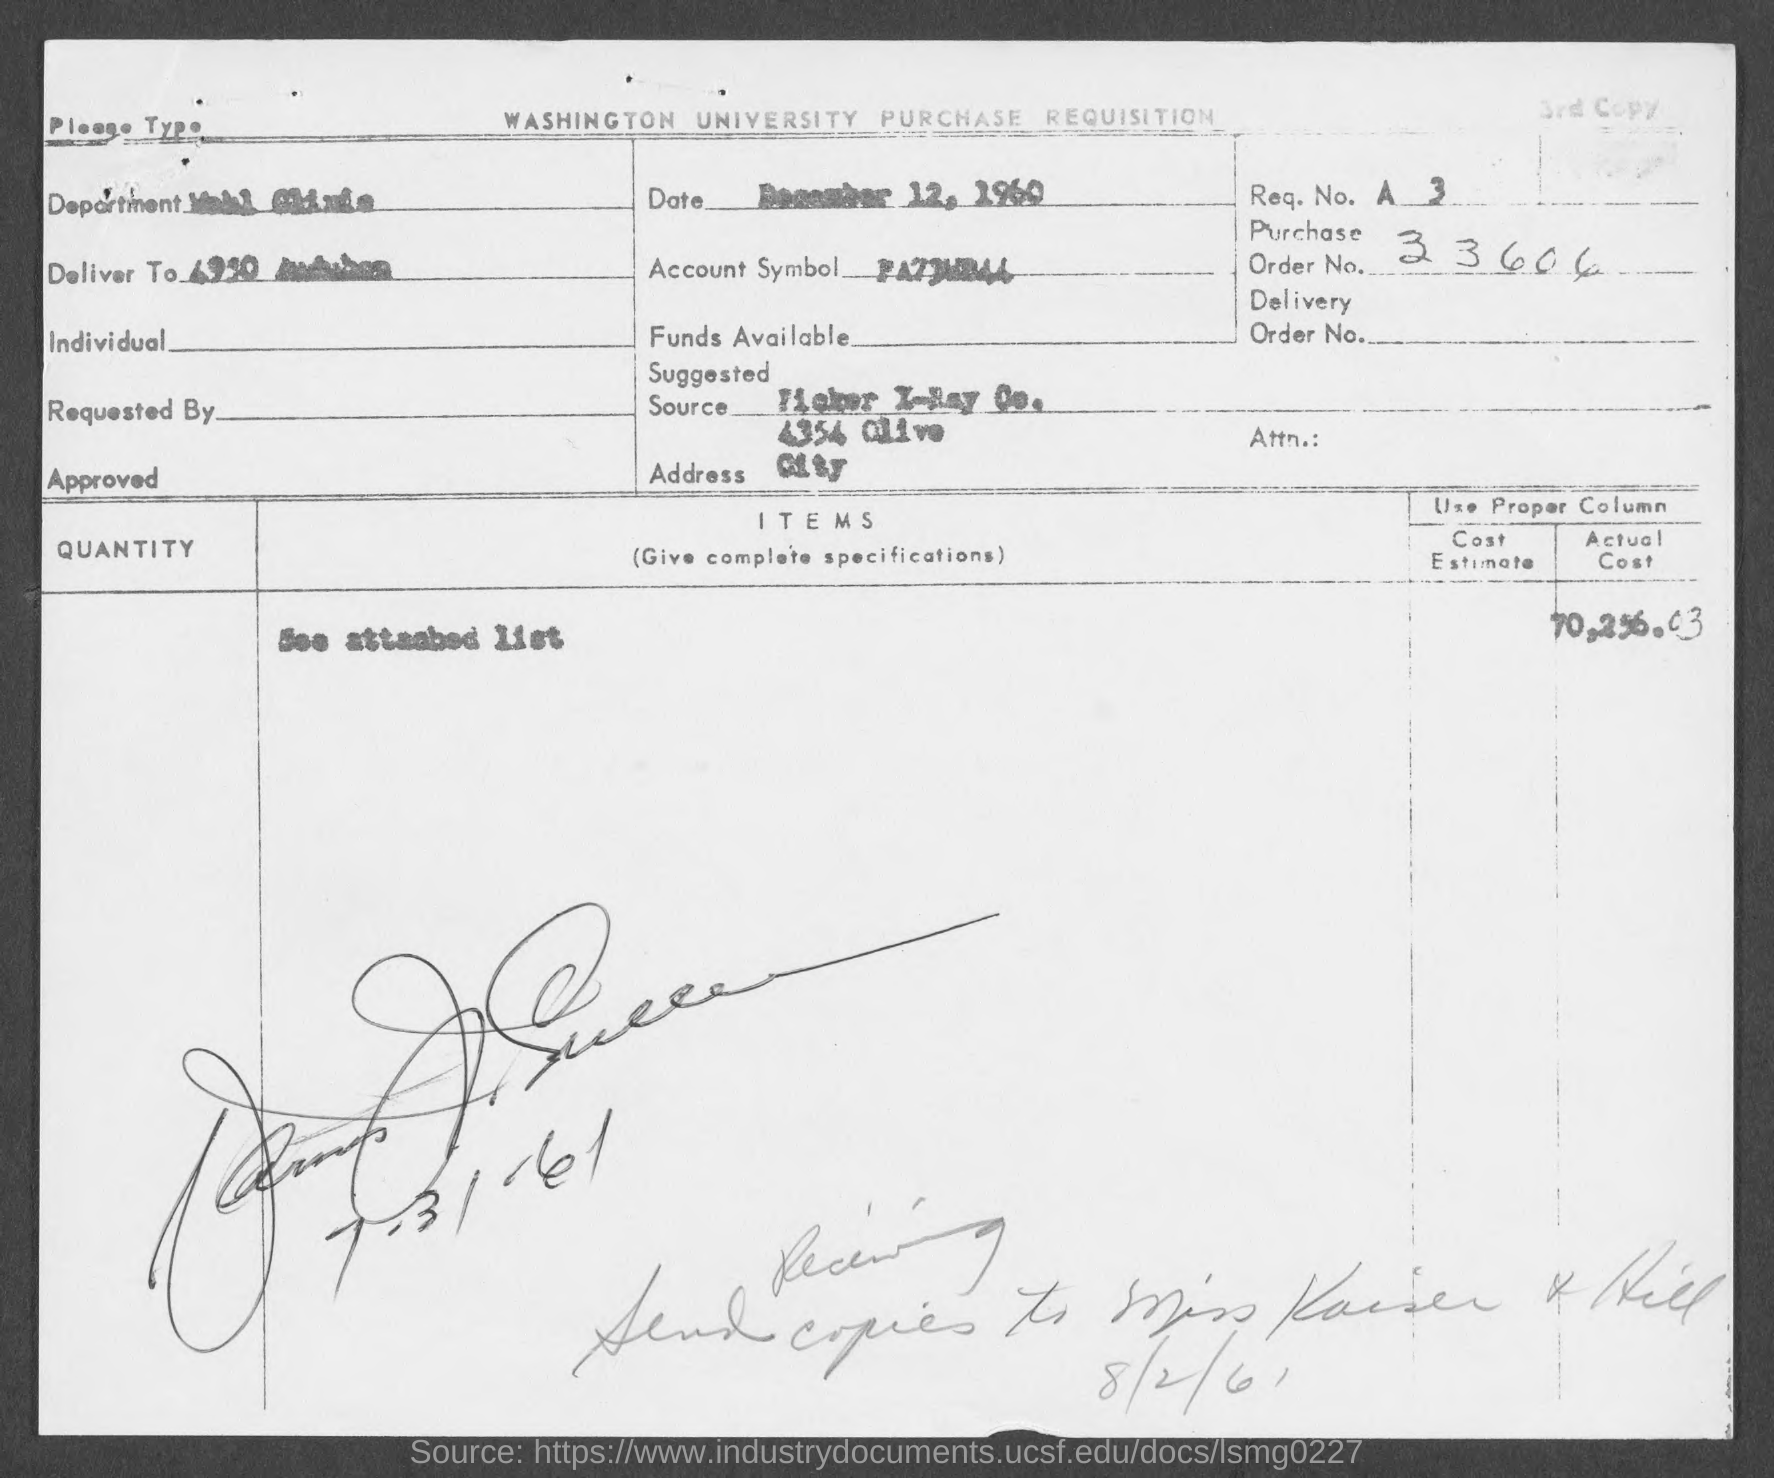Highlight a few significant elements in this photo. The question "what is the purchase order number?" is asking for information regarding a purchase order number that has 8 digits, starting with 33. The purchase order number is 33606 followed by a period and then two more digits. 